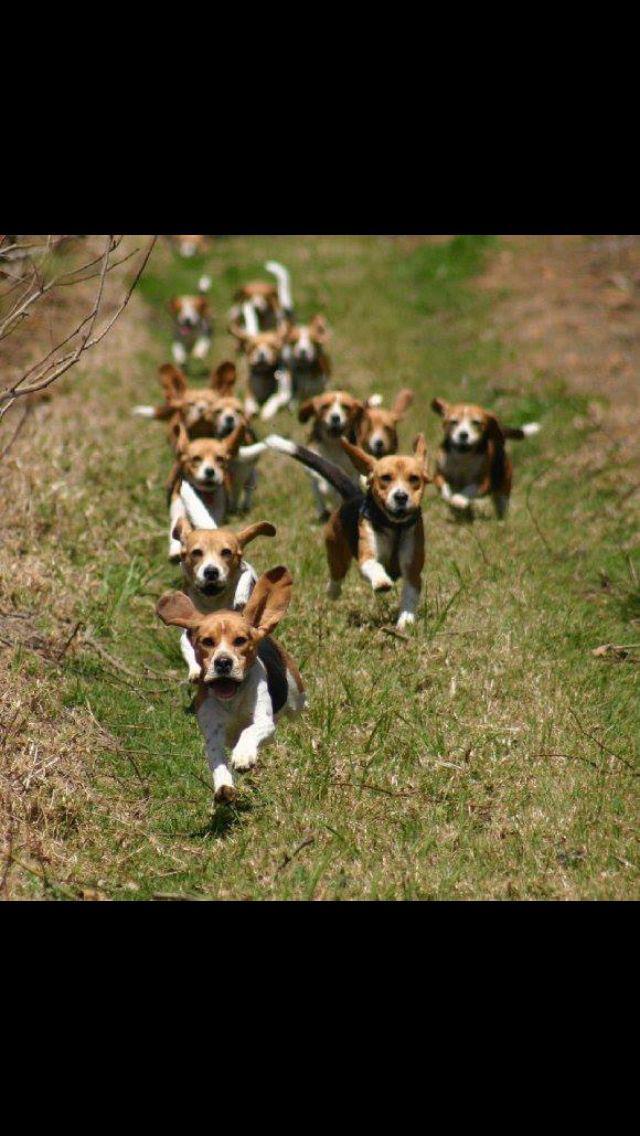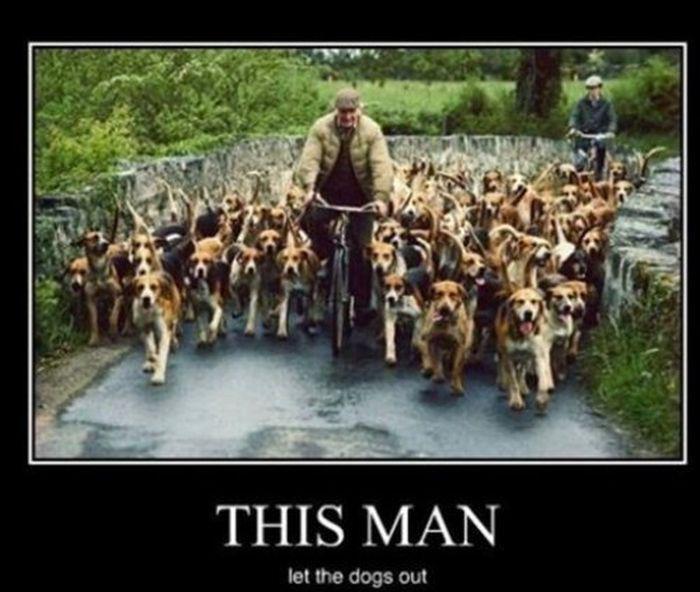The first image is the image on the left, the second image is the image on the right. Considering the images on both sides, is "dogs have ears flapping while they run" valid? Answer yes or no. Yes. 